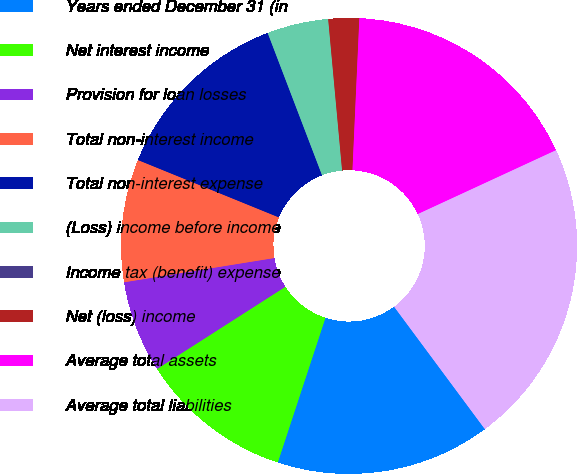Convert chart to OTSL. <chart><loc_0><loc_0><loc_500><loc_500><pie_chart><fcel>Years ended December 31 (in<fcel>Net interest income<fcel>Provision for loan losses<fcel>Total non-interest income<fcel>Total non-interest expense<fcel>(Loss) income before income<fcel>Income tax (benefit) expense<fcel>Net (loss) income<fcel>Average total assets<fcel>Average total liabilities<nl><fcel>15.22%<fcel>10.87%<fcel>6.52%<fcel>8.7%<fcel>13.04%<fcel>4.35%<fcel>0.0%<fcel>2.18%<fcel>17.39%<fcel>21.74%<nl></chart> 